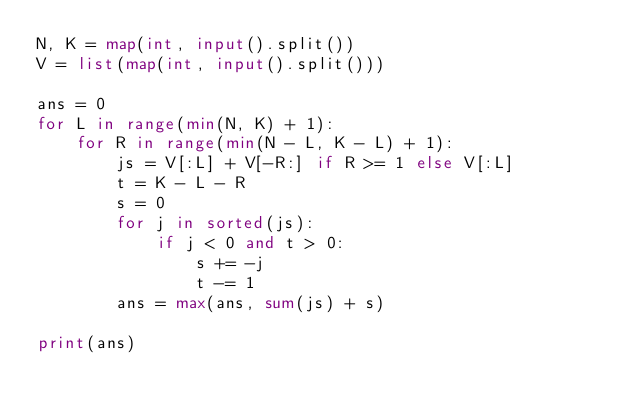Convert code to text. <code><loc_0><loc_0><loc_500><loc_500><_Python_>N, K = map(int, input().split())
V = list(map(int, input().split()))

ans = 0
for L in range(min(N, K) + 1):
    for R in range(min(N - L, K - L) + 1):
        js = V[:L] + V[-R:] if R >= 1 else V[:L]
        t = K - L - R
        s = 0
        for j in sorted(js):
            if j < 0 and t > 0:
                s += -j
                t -= 1
        ans = max(ans, sum(js) + s)

print(ans)
</code> 